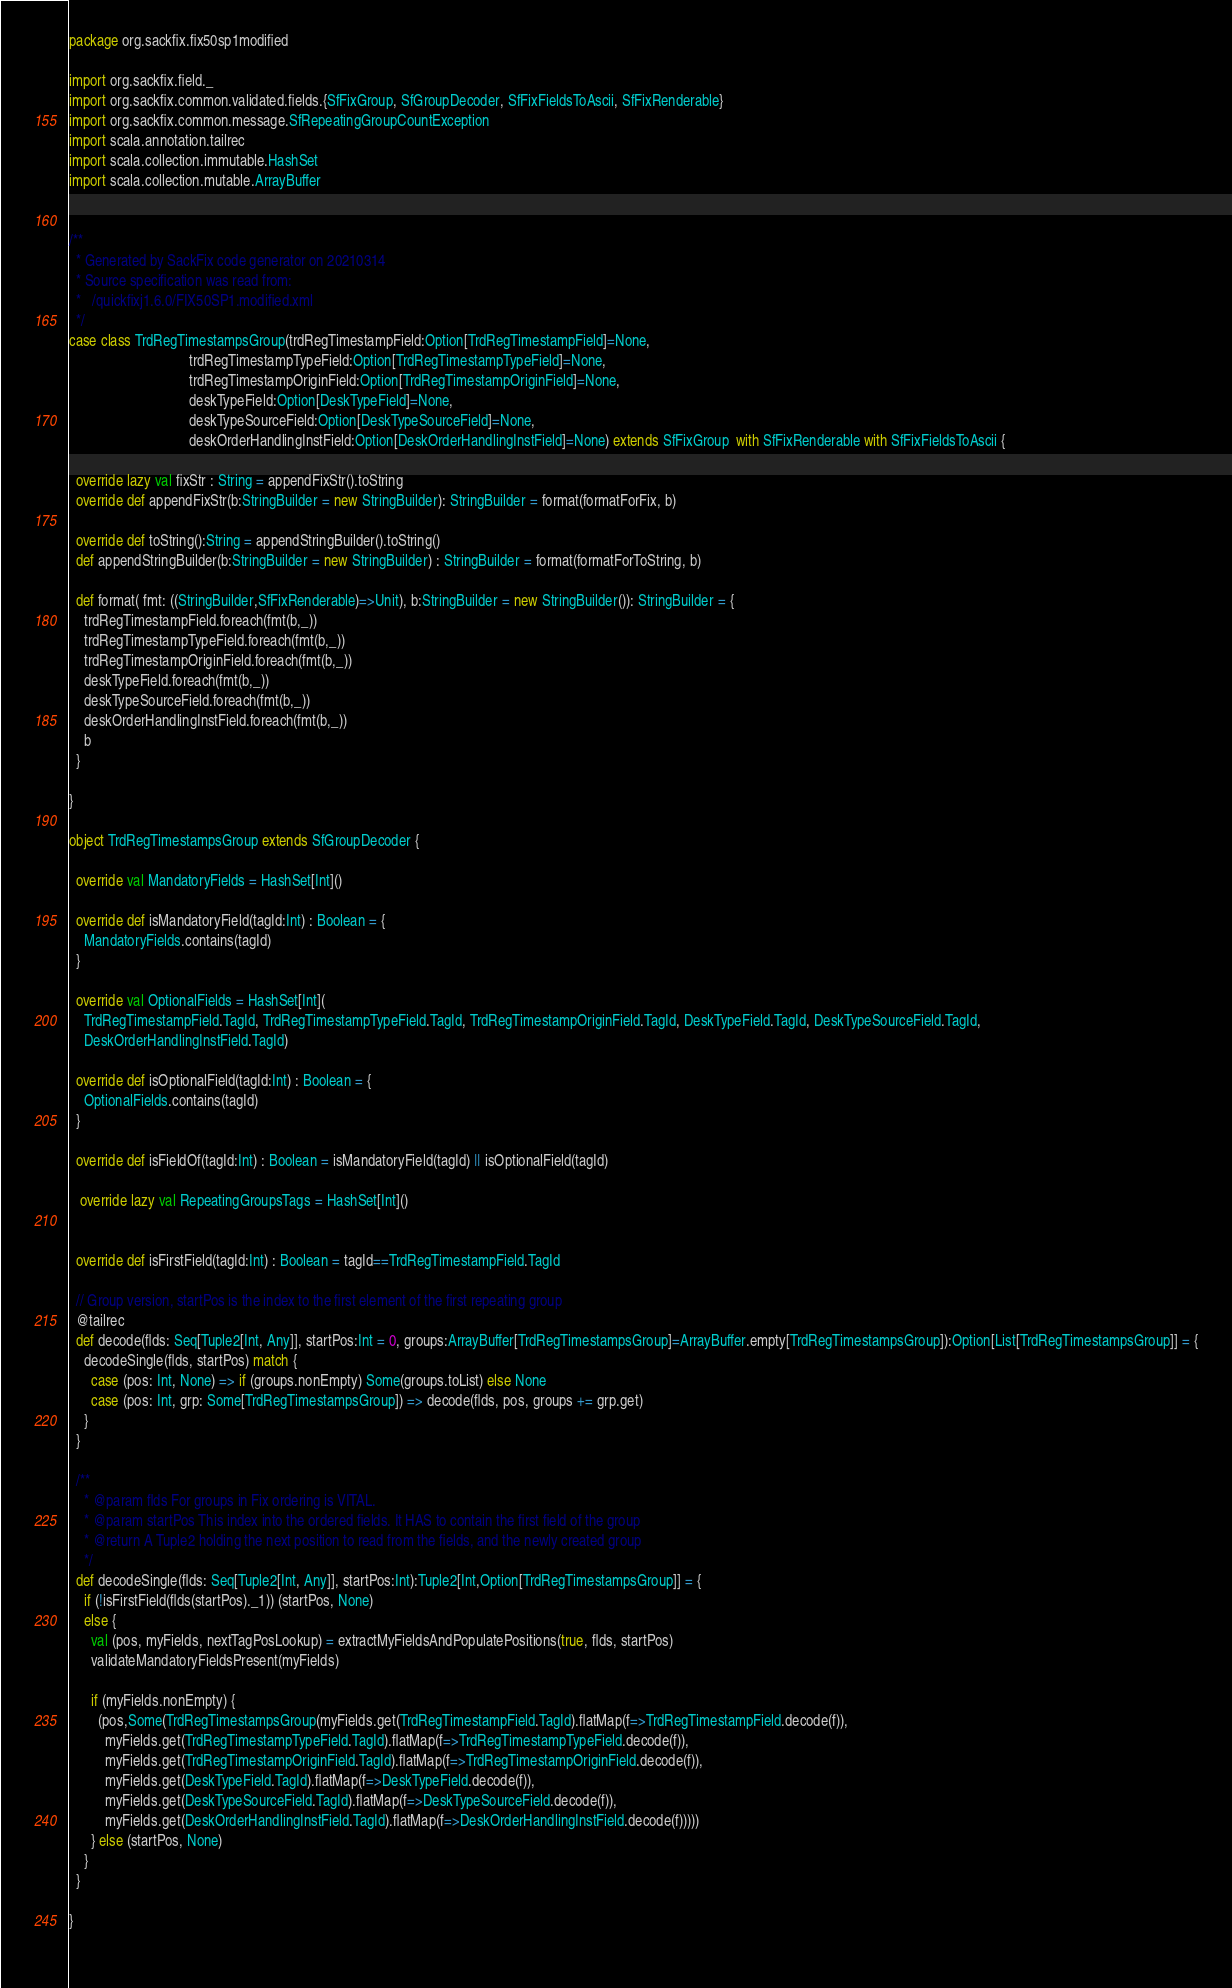<code> <loc_0><loc_0><loc_500><loc_500><_Scala_>package org.sackfix.fix50sp1modified

import org.sackfix.field._
import org.sackfix.common.validated.fields.{SfFixGroup, SfGroupDecoder, SfFixFieldsToAscii, SfFixRenderable}
import org.sackfix.common.message.SfRepeatingGroupCountException
import scala.annotation.tailrec
import scala.collection.immutable.HashSet
import scala.collection.mutable.ArrayBuffer


/**
  * Generated by SackFix code generator on 20210314
  * Source specification was read from:
  *   /quickfixj1.6.0/FIX50SP1.modified.xml
  */
case class TrdRegTimestampsGroup(trdRegTimestampField:Option[TrdRegTimestampField]=None,
                                 trdRegTimestampTypeField:Option[TrdRegTimestampTypeField]=None,
                                 trdRegTimestampOriginField:Option[TrdRegTimestampOriginField]=None,
                                 deskTypeField:Option[DeskTypeField]=None,
                                 deskTypeSourceField:Option[DeskTypeSourceField]=None,
                                 deskOrderHandlingInstField:Option[DeskOrderHandlingInstField]=None) extends SfFixGroup  with SfFixRenderable with SfFixFieldsToAscii {

  override lazy val fixStr : String = appendFixStr().toString
  override def appendFixStr(b:StringBuilder = new StringBuilder): StringBuilder = format(formatForFix, b)

  override def toString():String = appendStringBuilder().toString()
  def appendStringBuilder(b:StringBuilder = new StringBuilder) : StringBuilder = format(formatForToString, b)

  def format( fmt: ((StringBuilder,SfFixRenderable)=>Unit), b:StringBuilder = new StringBuilder()): StringBuilder = {
    trdRegTimestampField.foreach(fmt(b,_))
    trdRegTimestampTypeField.foreach(fmt(b,_))
    trdRegTimestampOriginField.foreach(fmt(b,_))
    deskTypeField.foreach(fmt(b,_))
    deskTypeSourceField.foreach(fmt(b,_))
    deskOrderHandlingInstField.foreach(fmt(b,_))
    b
  }

}
     
object TrdRegTimestampsGroup extends SfGroupDecoder {

  override val MandatoryFields = HashSet[Int]()

  override def isMandatoryField(tagId:Int) : Boolean = {
    MandatoryFields.contains(tagId) 
  }

  override val OptionalFields = HashSet[Int](
    TrdRegTimestampField.TagId, TrdRegTimestampTypeField.TagId, TrdRegTimestampOriginField.TagId, DeskTypeField.TagId, DeskTypeSourceField.TagId, 
    DeskOrderHandlingInstField.TagId)

  override def isOptionalField(tagId:Int) : Boolean = {
    OptionalFields.contains(tagId) 
  }

  override def isFieldOf(tagId:Int) : Boolean = isMandatoryField(tagId) || isOptionalField(tagId) 

   override lazy val RepeatingGroupsTags = HashSet[Int]()
  
      
  override def isFirstField(tagId:Int) : Boolean = tagId==TrdRegTimestampField.TagId 

  // Group version, startPos is the index to the first element of the first repeating group
  @tailrec
  def decode(flds: Seq[Tuple2[Int, Any]], startPos:Int = 0, groups:ArrayBuffer[TrdRegTimestampsGroup]=ArrayBuffer.empty[TrdRegTimestampsGroup]):Option[List[TrdRegTimestampsGroup]] = {
    decodeSingle(flds, startPos) match {
      case (pos: Int, None) => if (groups.nonEmpty) Some(groups.toList) else None
      case (pos: Int, grp: Some[TrdRegTimestampsGroup]) => decode(flds, pos, groups += grp.get)
    }
  }

  /**
    * @param flds For groups in Fix ordering is VITAL.
    * @param startPos This index into the ordered fields. It HAS to contain the first field of the group
    * @return A Tuple2 holding the next position to read from the fields, and the newly created group
    */
  def decodeSingle(flds: Seq[Tuple2[Int, Any]], startPos:Int):Tuple2[Int,Option[TrdRegTimestampsGroup]] = {
    if (!isFirstField(flds(startPos)._1)) (startPos, None)
    else {
      val (pos, myFields, nextTagPosLookup) = extractMyFieldsAndPopulatePositions(true, flds, startPos)
      validateMandatoryFieldsPresent(myFields)

      if (myFields.nonEmpty) {
        (pos,Some(TrdRegTimestampsGroup(myFields.get(TrdRegTimestampField.TagId).flatMap(f=>TrdRegTimestampField.decode(f)),
          myFields.get(TrdRegTimestampTypeField.TagId).flatMap(f=>TrdRegTimestampTypeField.decode(f)),
          myFields.get(TrdRegTimestampOriginField.TagId).flatMap(f=>TrdRegTimestampOriginField.decode(f)),
          myFields.get(DeskTypeField.TagId).flatMap(f=>DeskTypeField.decode(f)),
          myFields.get(DeskTypeSourceField.TagId).flatMap(f=>DeskTypeSourceField.decode(f)),
          myFields.get(DeskOrderHandlingInstField.TagId).flatMap(f=>DeskOrderHandlingInstField.decode(f)))))
      } else (startPos, None)
    }
  }
    
}
     </code> 